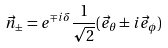Convert formula to latex. <formula><loc_0><loc_0><loc_500><loc_500>\vec { n } _ { \pm } = e ^ { \mp i \delta } \frac { 1 } { \sqrt { 2 } } ( \vec { e } _ { \theta } \pm i \vec { e } _ { \phi } )</formula> 